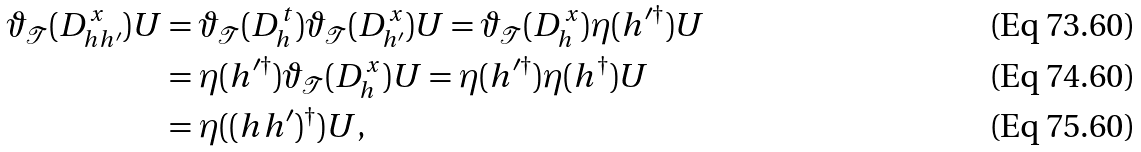Convert formula to latex. <formula><loc_0><loc_0><loc_500><loc_500>\vartheta _ { \mathcal { T } } ( D _ { h h ^ { \prime } } ^ { x } ) U & = \vartheta _ { \mathcal { T } } ( D _ { h } ^ { t } ) \vartheta _ { \mathcal { T } } ( D _ { h ^ { \prime } } ^ { x } ) U = \vartheta _ { \mathcal { T } } ( D _ { h } ^ { x } ) \eta ( h ^ { \prime \dagger } ) U \\ & = \eta ( h ^ { \prime \dagger } ) \vartheta _ { \mathcal { T } } ( D _ { h } ^ { x } ) U = \eta ( h ^ { \prime \dagger } ) \eta ( h ^ { \dagger } ) U \\ & = \eta ( ( h h ^ { \prime } ) ^ { \dagger } ) U ,</formula> 